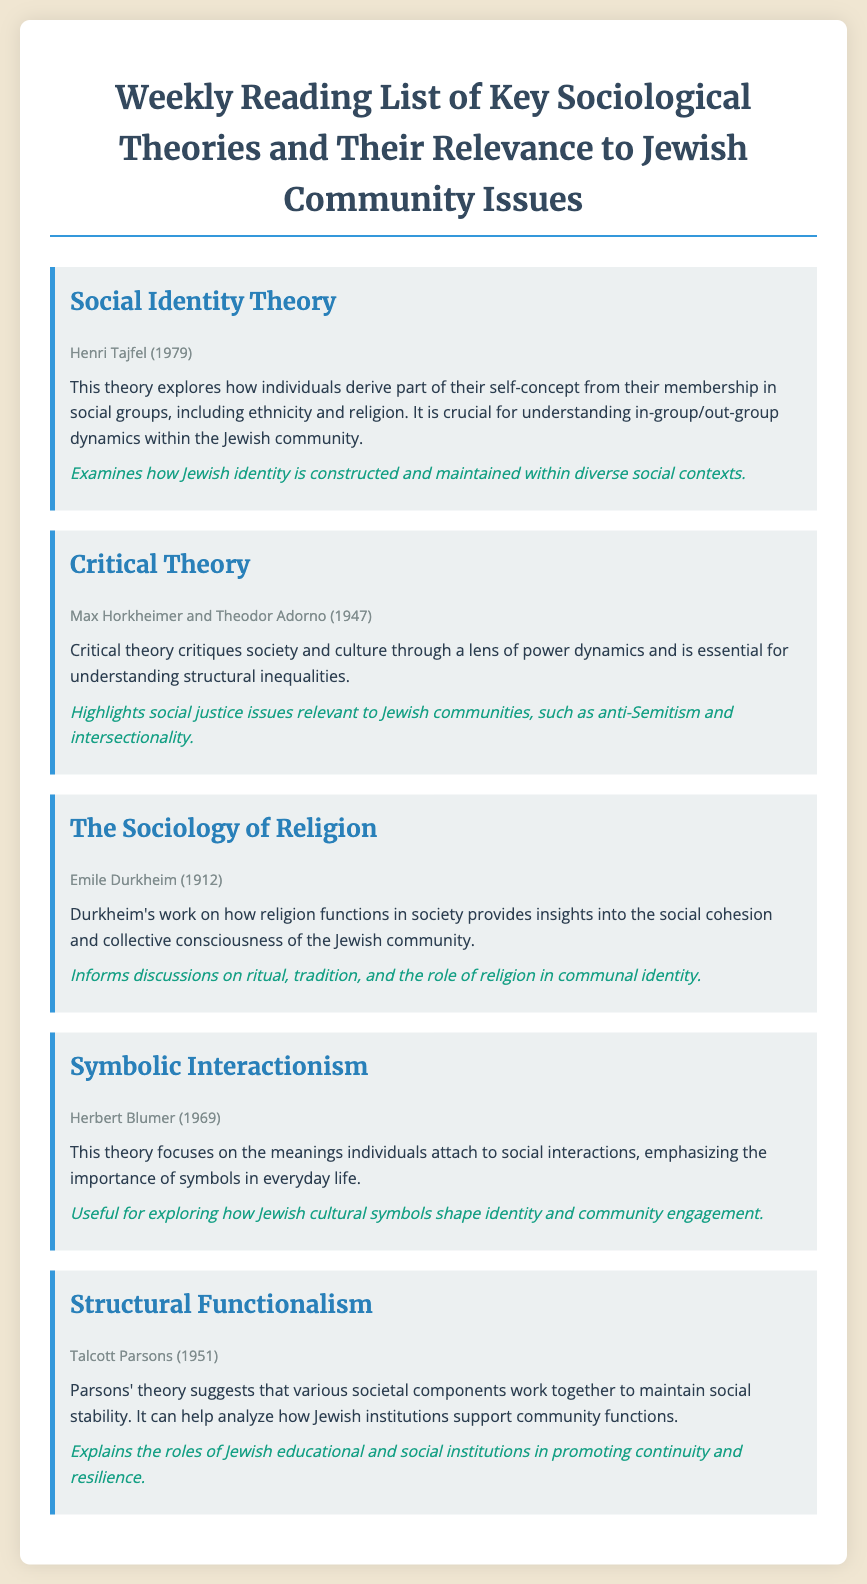What is the title of the reading list? The title is explicitly stated at the beginning of the document.
Answer: Weekly Reading List of Key Sociological Theories and Their Relevance to Jewish Community Issues Who authored the Critical Theory? The author is mentioned in the metadata of the entry for Critical Theory.
Answer: Max Horkheimer and Theodor Adorno In what year was Social Identity Theory published? The publication year is indicated in the metadata of the entry for Social Identity Theory.
Answer: 1979 What theory focuses on the meanings individuals attach to social interactions? This is described in the entry for Symbolic Interactionism.
Answer: Symbolic Interactionism What does Structural Functionalism explain? The document summarizes the explanation in the entry for Structural Functionalism.
Answer: The roles of Jewish educational and social institutions in promoting continuity and resilience What is the relevance of The Sociology of Religion? The relevance is directly stated in the entry for The Sociology of Religion.
Answer: Informs discussions on ritual, tradition, and the role of religion in communal identity 